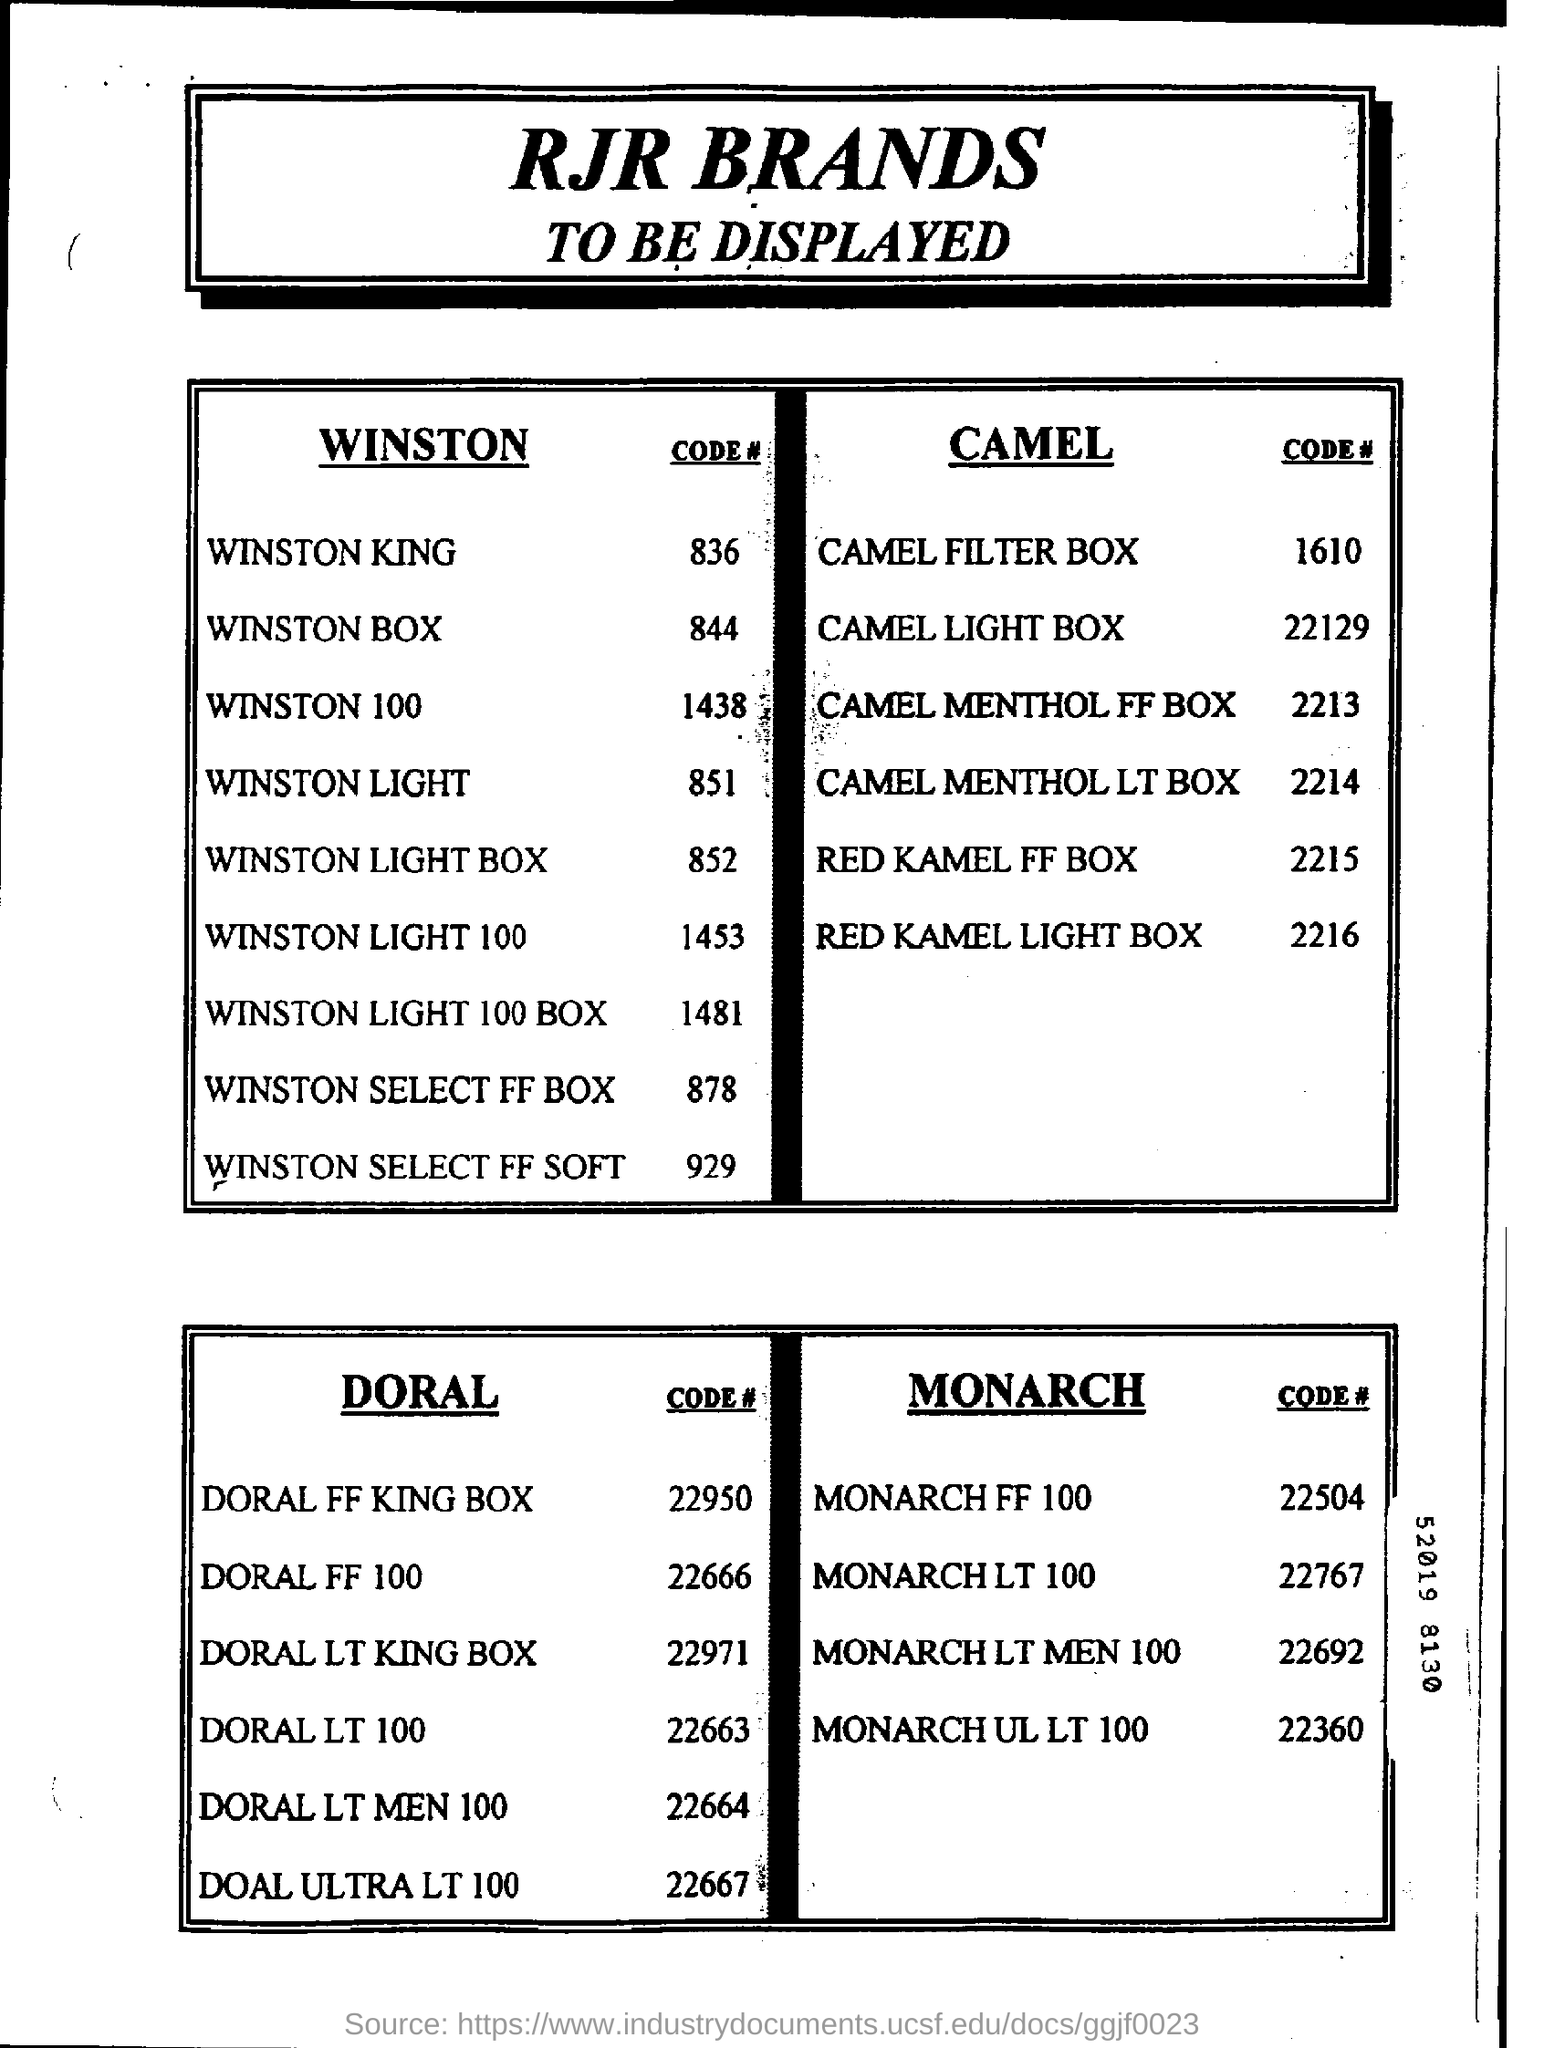What is the Code of WINSTON KING ?
Your answer should be very brief. 836. What is the Code of RED KAMEL LIGHT BOX ?
Provide a succinct answer. 2216. What is the Code of WINSTON 100 ?
Your response must be concise. 1438. What is the Code of WINSTON LIGHT BOX ?
Offer a terse response. 852. What is the Code of CAMEL FILTER BOX ?
Make the answer very short. 1610. What is the Code of WINSTON SELECT FF BOX ?
Keep it short and to the point. 878. What is the Code of DORAL FF 100 ?
Offer a very short reply. 22666. What is the Code of MONARCHLT 100 ?
Ensure brevity in your answer.  22767. What is the Code of DORAL LT 100 ?
Give a very brief answer. 22663. 